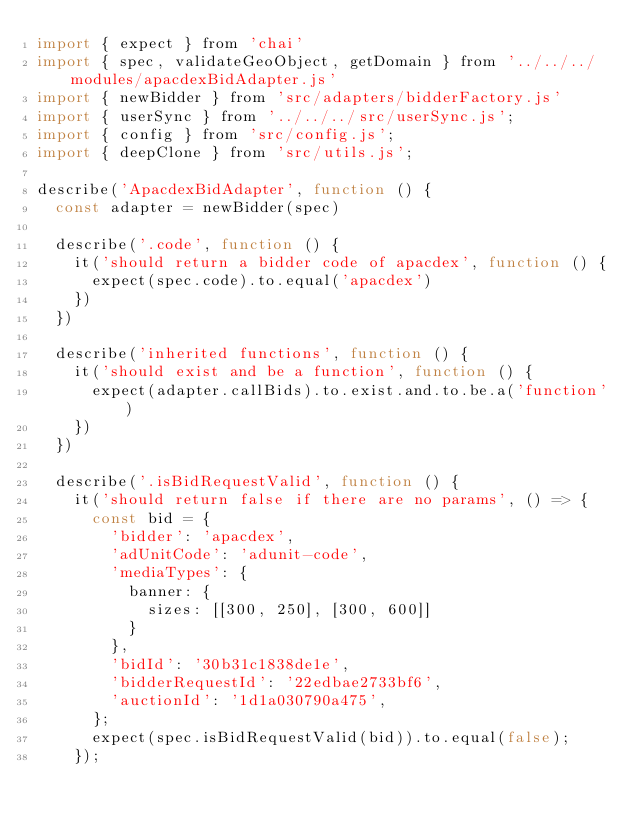<code> <loc_0><loc_0><loc_500><loc_500><_JavaScript_>import { expect } from 'chai'
import { spec, validateGeoObject, getDomain } from '../../../modules/apacdexBidAdapter.js'
import { newBidder } from 'src/adapters/bidderFactory.js'
import { userSync } from '../../../src/userSync.js';
import { config } from 'src/config.js';
import { deepClone } from 'src/utils.js';

describe('ApacdexBidAdapter', function () {
  const adapter = newBidder(spec)

  describe('.code', function () {
    it('should return a bidder code of apacdex', function () {
      expect(spec.code).to.equal('apacdex')
    })
  })

  describe('inherited functions', function () {
    it('should exist and be a function', function () {
      expect(adapter.callBids).to.exist.and.to.be.a('function')
    })
  })

  describe('.isBidRequestValid', function () {
    it('should return false if there are no params', () => {
      const bid = {
        'bidder': 'apacdex',
        'adUnitCode': 'adunit-code',
        'mediaTypes': {
          banner: {
            sizes: [[300, 250], [300, 600]]
          }
        },
        'bidId': '30b31c1838de1e',
        'bidderRequestId': '22edbae2733bf6',
        'auctionId': '1d1a030790a475',
      };
      expect(spec.isBidRequestValid(bid)).to.equal(false);
    });
</code> 